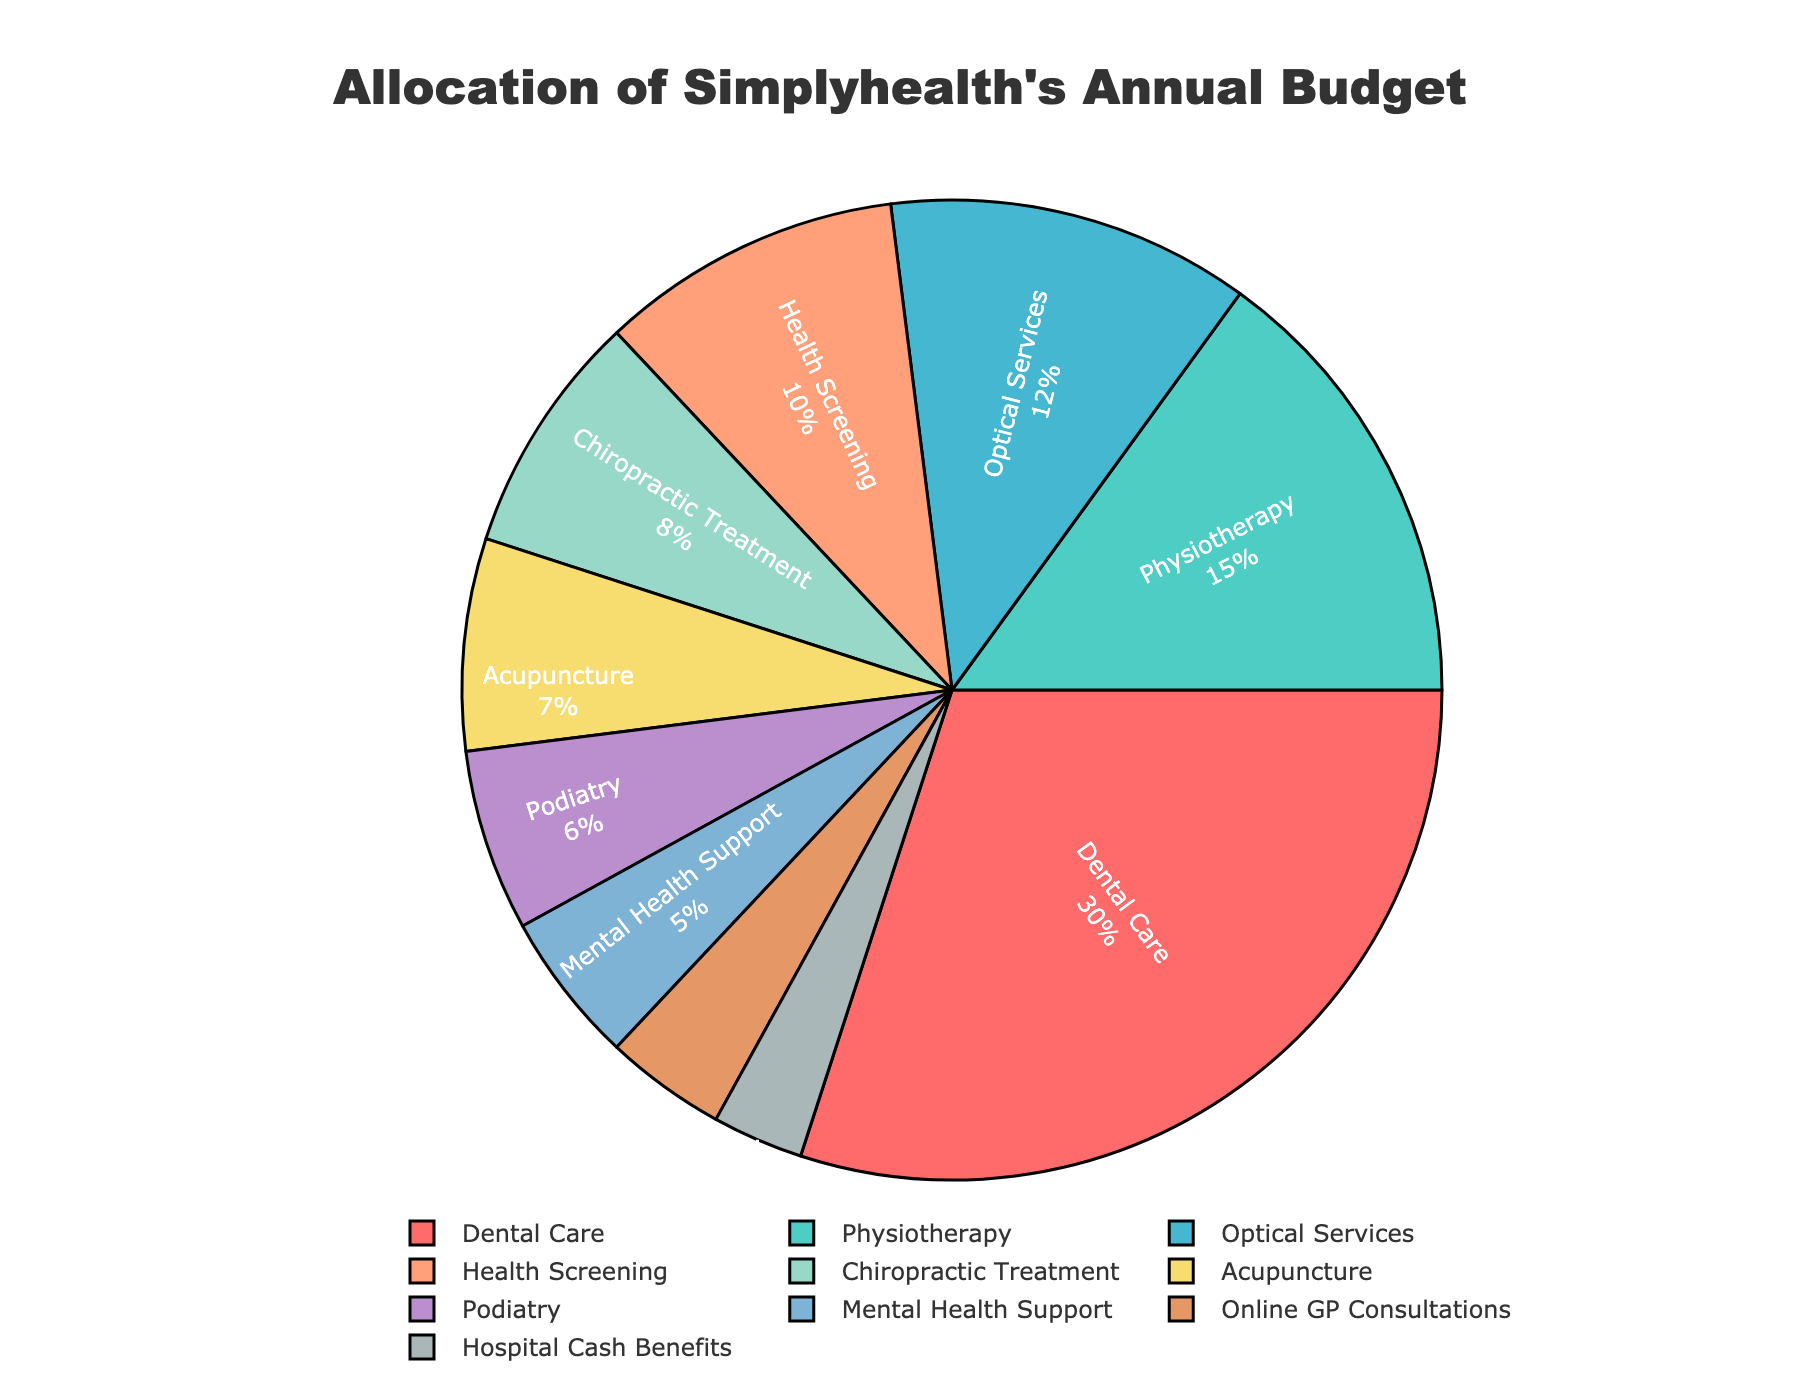What percentage of the budget is allocated to services other than Dental Care? To find the percentage allocated to services other than Dental Care, subtract the percentage of Dental Care from 100%. So, 100% - 30% = 70%.
Answer: 70% What is the combined budget allocation for Health Screening, Chiropractic Treatment, Acupuncture, and Podiatry? Sum the percentage allocations of these services: Health Screening (10%) + Chiropractic Treatment (8%) + Acupuncture (7%) + Podiatry (6%) = 31%.
Answer: 31% What is the difference in budget allocation between Physiotherapy and Mental Health Support? Subtract the percentage allocation of Mental Health Support from Physiotherapy: 15% - 5% = 10%.
Answer: 10% Which service has the smallest budget allocation, and what is its percentage? Based on the pie chart, the service with the smallest budget allocation is Hospital Cash Benefits at 3%.
Answer: Hospital Cash Benefits, 3% What is the average budget allocation for Optical Services, Health Screening, and Chiropractic Treatment? To find the average, sum the percentages and divide by the number of services: (12% + 10% + 8%) / 3 = 10%.
Answer: 10% How does the budget allocation for Online GP Consultations compare to that for Podiatry? Online GP Consultations have a budget of 4%, while Podiatry has 6%. Since 4% is less than 6%, Online GP Consultations have a smaller budget allocation than Podiatry.
Answer: Less Is the budget allocation for Acupuncture greater than the allocation for Hospital Cash Benefits and Mental Health Support combined? Combine the allocations for Hospital Cash Benefits (3%) and Mental Health Support (5%) to get 8%. Since Acupuncture has 7%, it is not greater than 8%.
Answer: No Which service has the second-largest budget allocation, and what is its percentage? The second-largest budget allocation goes to Physiotherapy at 15%.
Answer: Physiotherapy, 15% What is the cumulative budget allocation for services related to physical health (Dental Care, Physiotherapy, Chiropractic Treatment, and Podiatry)? Sum the percent allocations: Dental Care (30%) + Physiotherapy (15%) + Chiropractic Treatment (8%) + Podiatry (6%) = 59%.
Answer: 59% Which slices of the pie chart are represented in shades of blue or green, and what services do they correspond to? Based on the color scheme provided, the blue shades are likely for Optical Services and Online GP Consultations, and green shades for Physiotherapy and Podiatry.
Answer: Optical Services and Online GP Consultations (blue), Physiotherapy and Podiatry (green) 